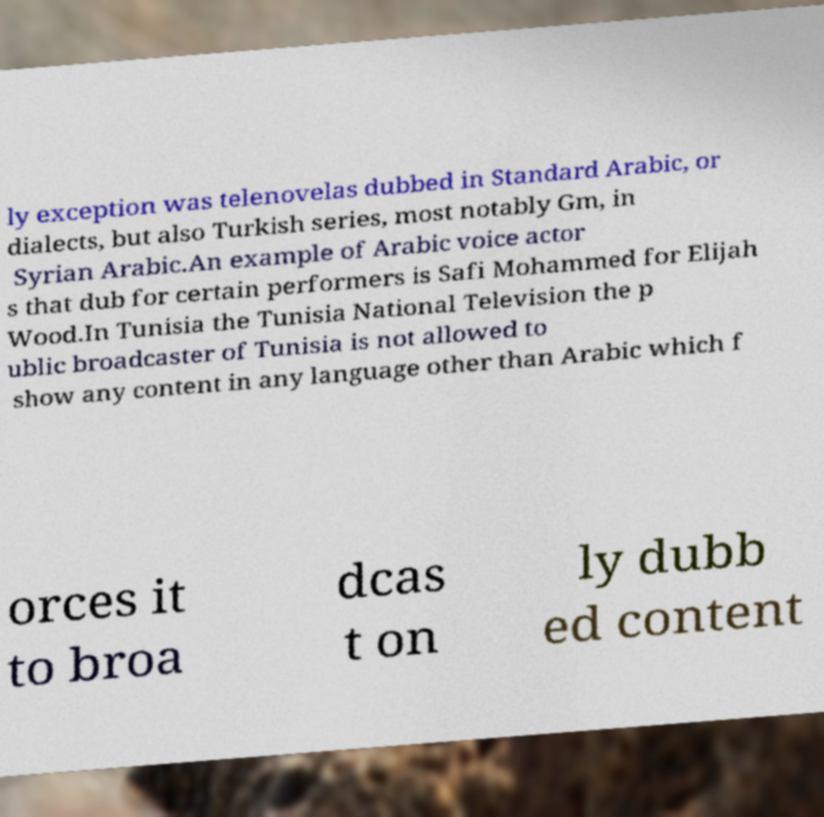For documentation purposes, I need the text within this image transcribed. Could you provide that? ly exception was telenovelas dubbed in Standard Arabic, or dialects, but also Turkish series, most notably Gm, in Syrian Arabic.An example of Arabic voice actor s that dub for certain performers is Safi Mohammed for Elijah Wood.In Tunisia the Tunisia National Television the p ublic broadcaster of Tunisia is not allowed to show any content in any language other than Arabic which f orces it to broa dcas t on ly dubb ed content 